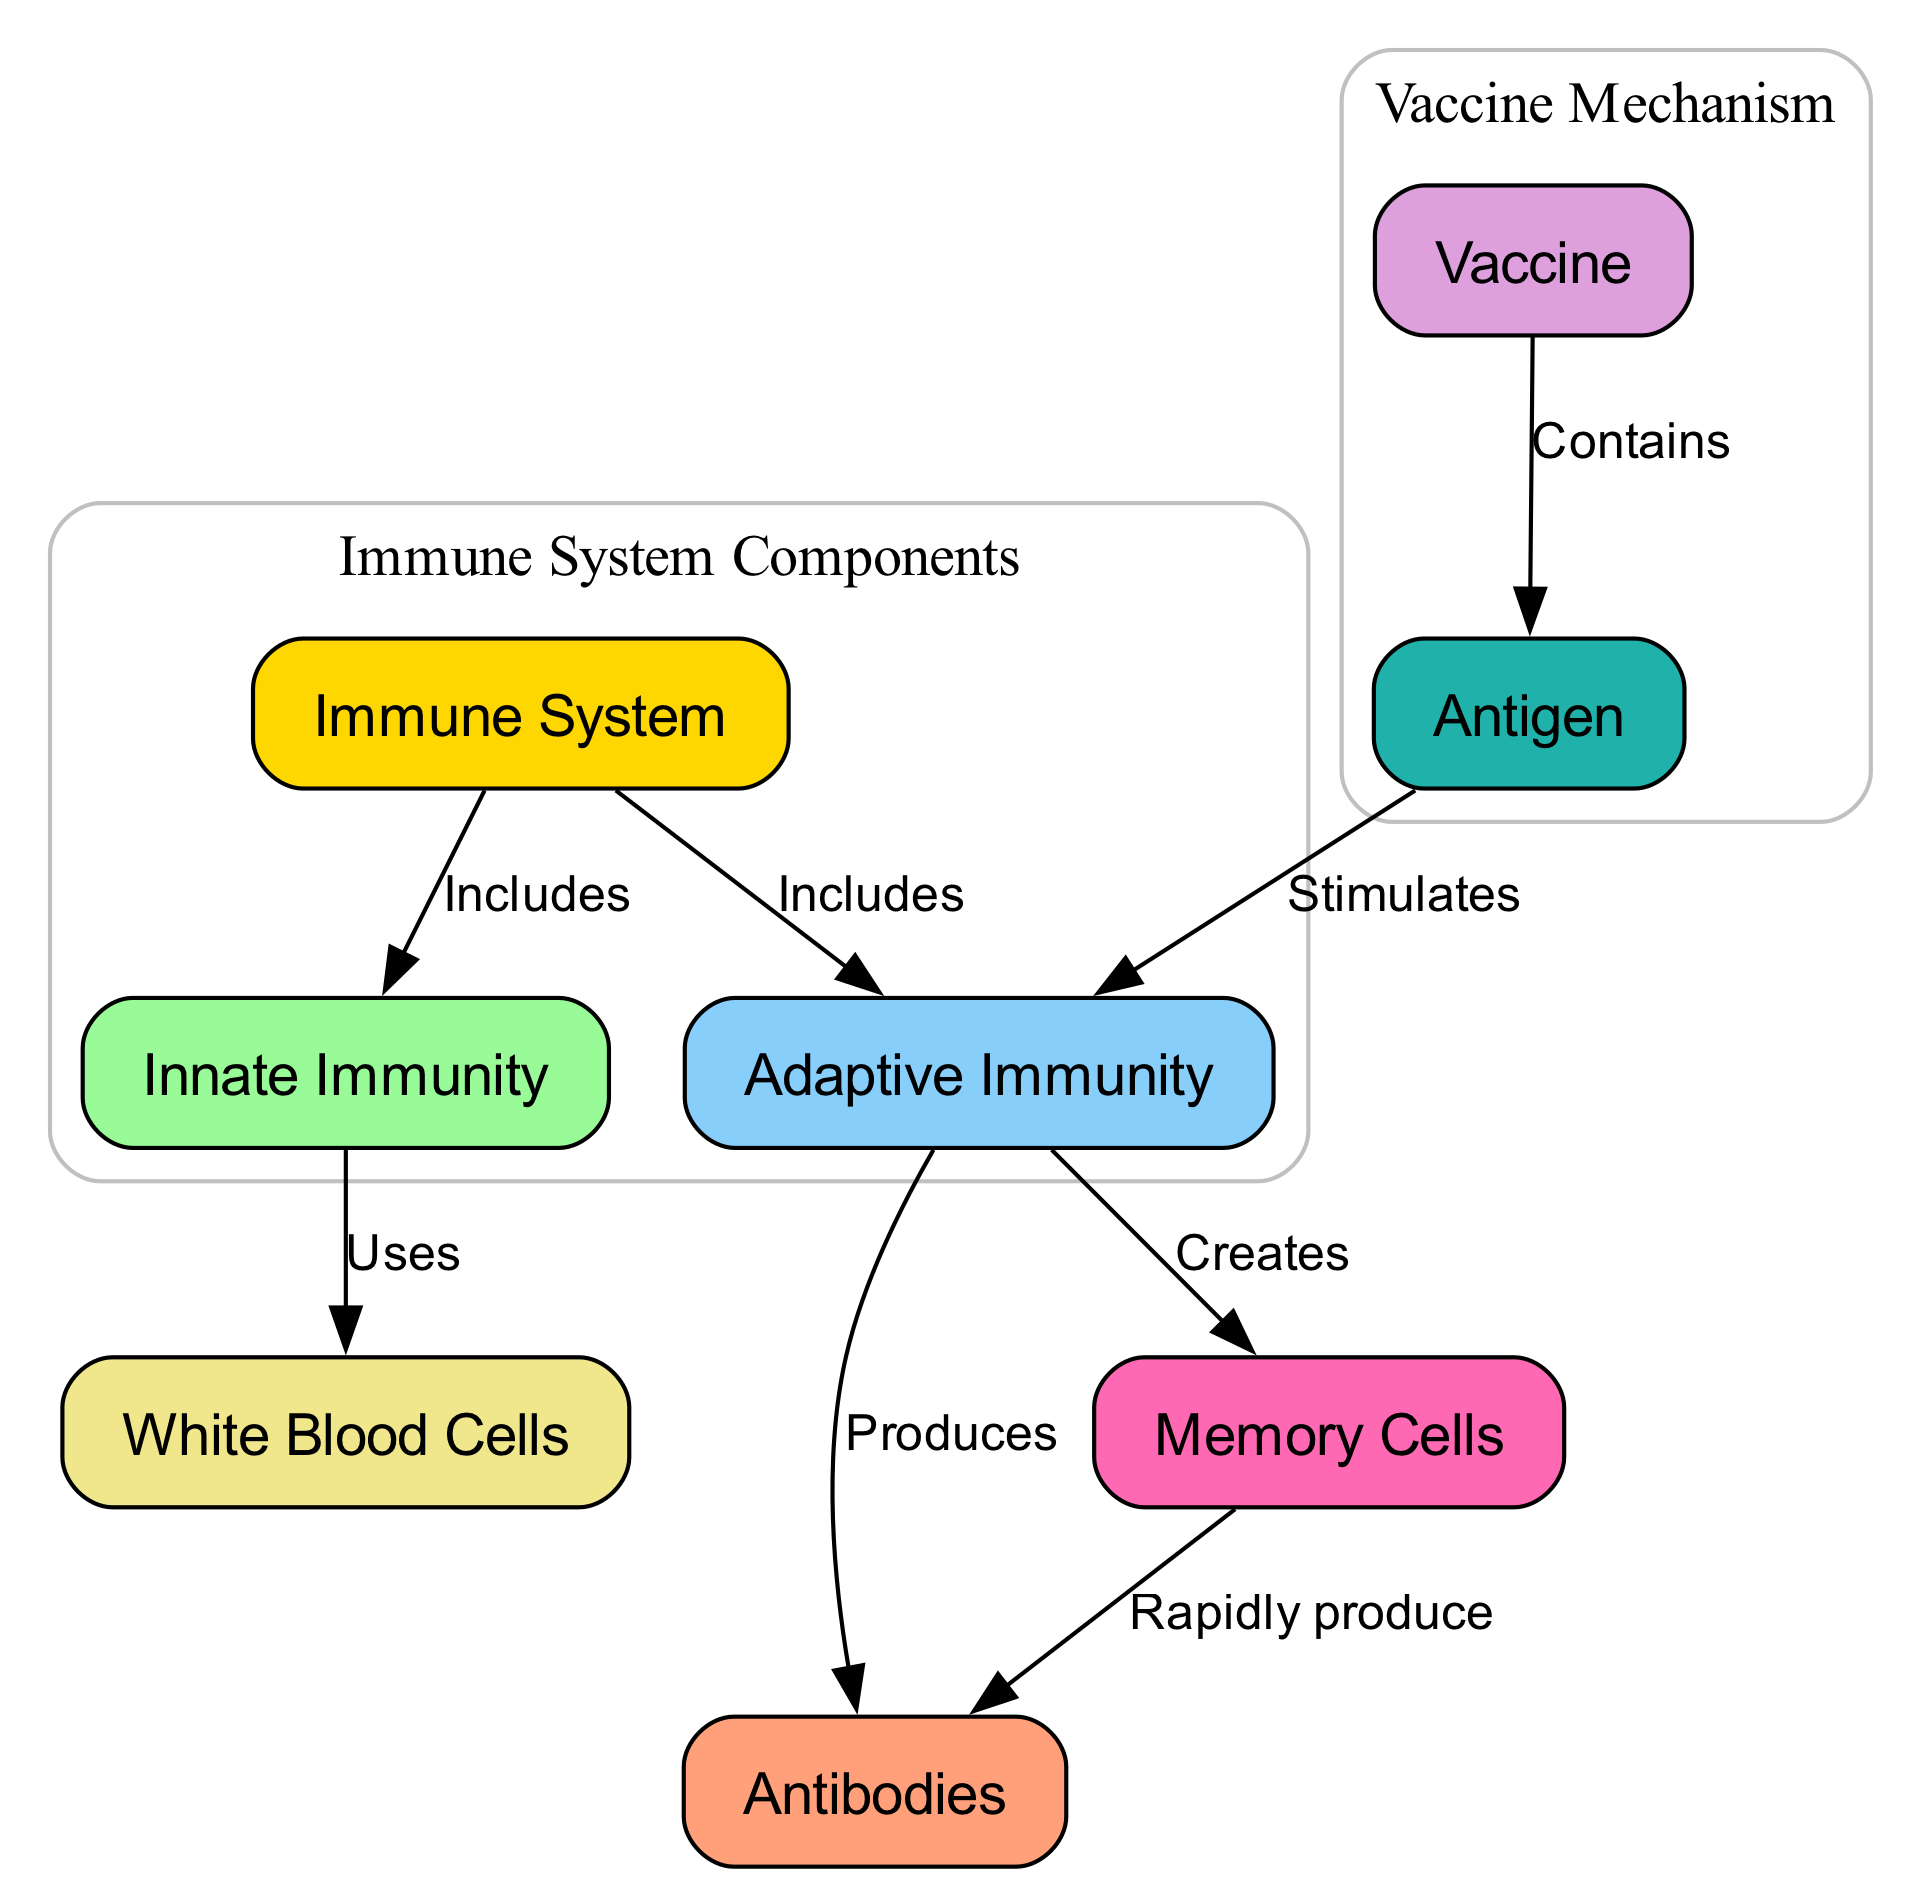What are the two main components of the immune system? The diagram shows that the immune system includes "Innate Immunity" and "Adaptive Immunity." These are clearly labeled as direct branches from the "Immune System" node.
Answer: Innate Immunity, Adaptive Immunity Which type of immunity uses white blood cells? The diagram indicates that "Innate Immunity" uses "White Blood Cells," as shown in the relationship labeled "Uses." This direct connection identifies the role of white blood cells specifically within that immunity type.
Answer: Innate Immunity What do vaccines contain according to the diagram? The diagram illustrates that "Vaccines" contain "Antigens," as indicated by the connection labeled "Contains." This directly states what vaccines have as part of their function in immunization.
Answer: Antigen How do antigens affect adaptive immunity? The diagram specifies that "Antigen" stimulates "Adaptive Immunity," shown by the connection labeled "Stimulates." Therefore, the presence of an antigen activates the adaptive immune response.
Answer: Stimulates What is created by adaptive immunity? According to the diagram, "Memory Cells" are created by "Adaptive Immunity," as indicated by the connection labeled "Creates." This directly shows the output of the adaptive immune response.
Answer: Memory Cells How do memory cells function in the immune response? The diagram indicates that "Memory Cells" can rapidly produce "Antibodies," as shown by the relationship labeled "Rapidly produce." This explains how memory cells contribute to a swift immune reaction upon re-exposure to an antigen.
Answer: Rapidly produce Antibodies What component directly produces antibodies? The diagram shows that "Adaptive Immunity" produces "Antibodies," evidenced by the relationship labeled "Produces." Thus, the adaptive immunity is responsible for generating antibodies to fight infections.
Answer: Antibodies How many nodes are present in the diagram? The diagram includes a total of 8 nodes, listed as individual components of the immune system and vaccine function. Each node can be counted independently to determine the total.
Answer: 8 What links vaccines to the immune system? The connection in the diagram shows that a "Vaccine" contains an "Antigen," which then stimulates "Adaptive Immunity." This series of relationships illustrates how vaccines engage with the immune system.
Answer: Stimulates Adaptive Immunity 